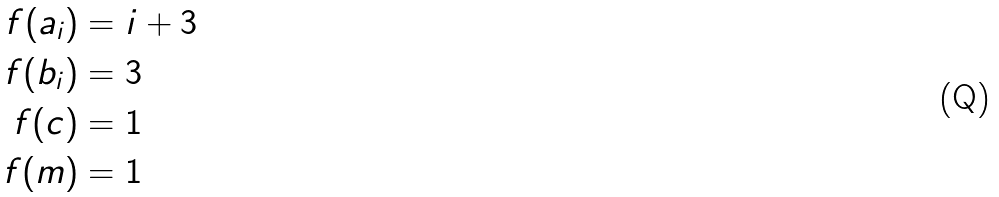<formula> <loc_0><loc_0><loc_500><loc_500>f ( a _ { i } ) & = i + 3 \\ f ( b _ { i } ) & = 3 \\ f ( c ) & = 1 \\ f ( m ) & = 1</formula> 